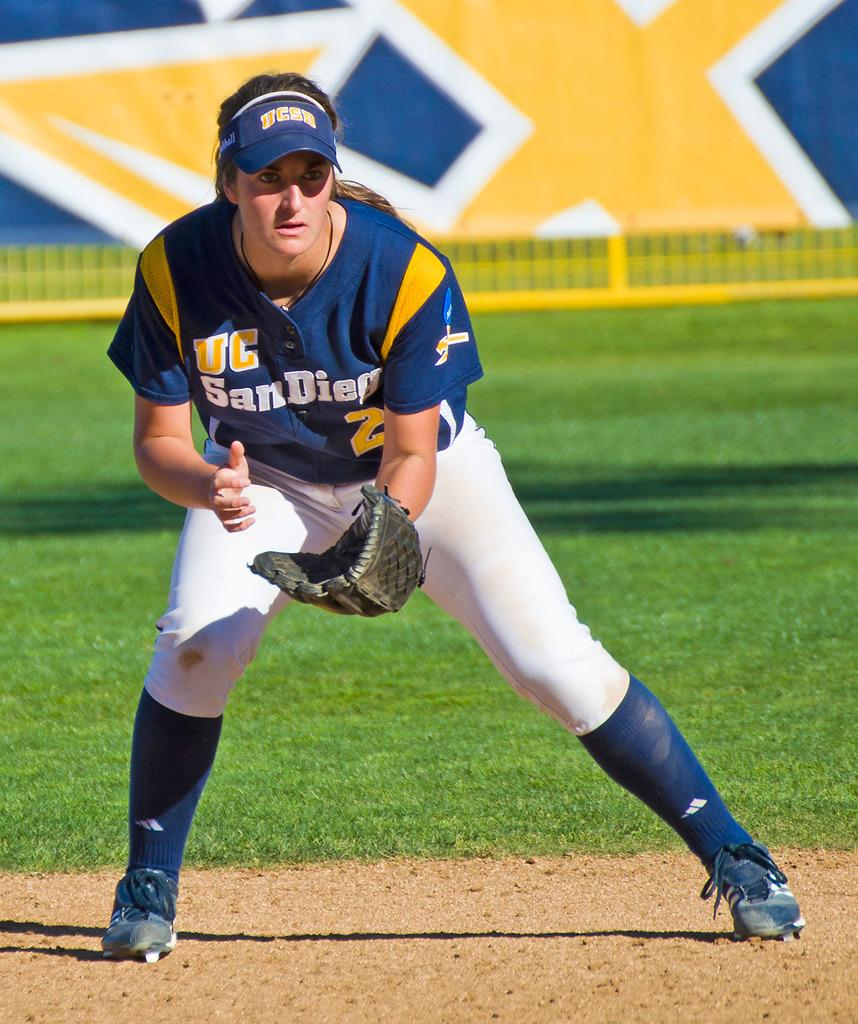<image>
Provide a brief description of the given image. player number 2 from UC San Diego on the baseball field ready to catch a ball 